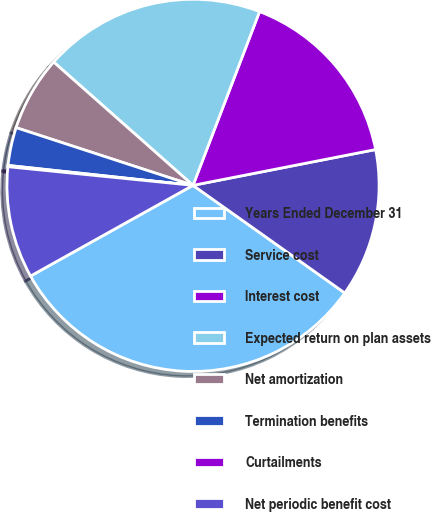Convert chart. <chart><loc_0><loc_0><loc_500><loc_500><pie_chart><fcel>Years Ended December 31<fcel>Service cost<fcel>Interest cost<fcel>Expected return on plan assets<fcel>Net amortization<fcel>Termination benefits<fcel>Curtailments<fcel>Net periodic benefit cost<nl><fcel>32.08%<fcel>12.9%<fcel>16.1%<fcel>19.29%<fcel>6.51%<fcel>3.31%<fcel>0.11%<fcel>9.7%<nl></chart> 